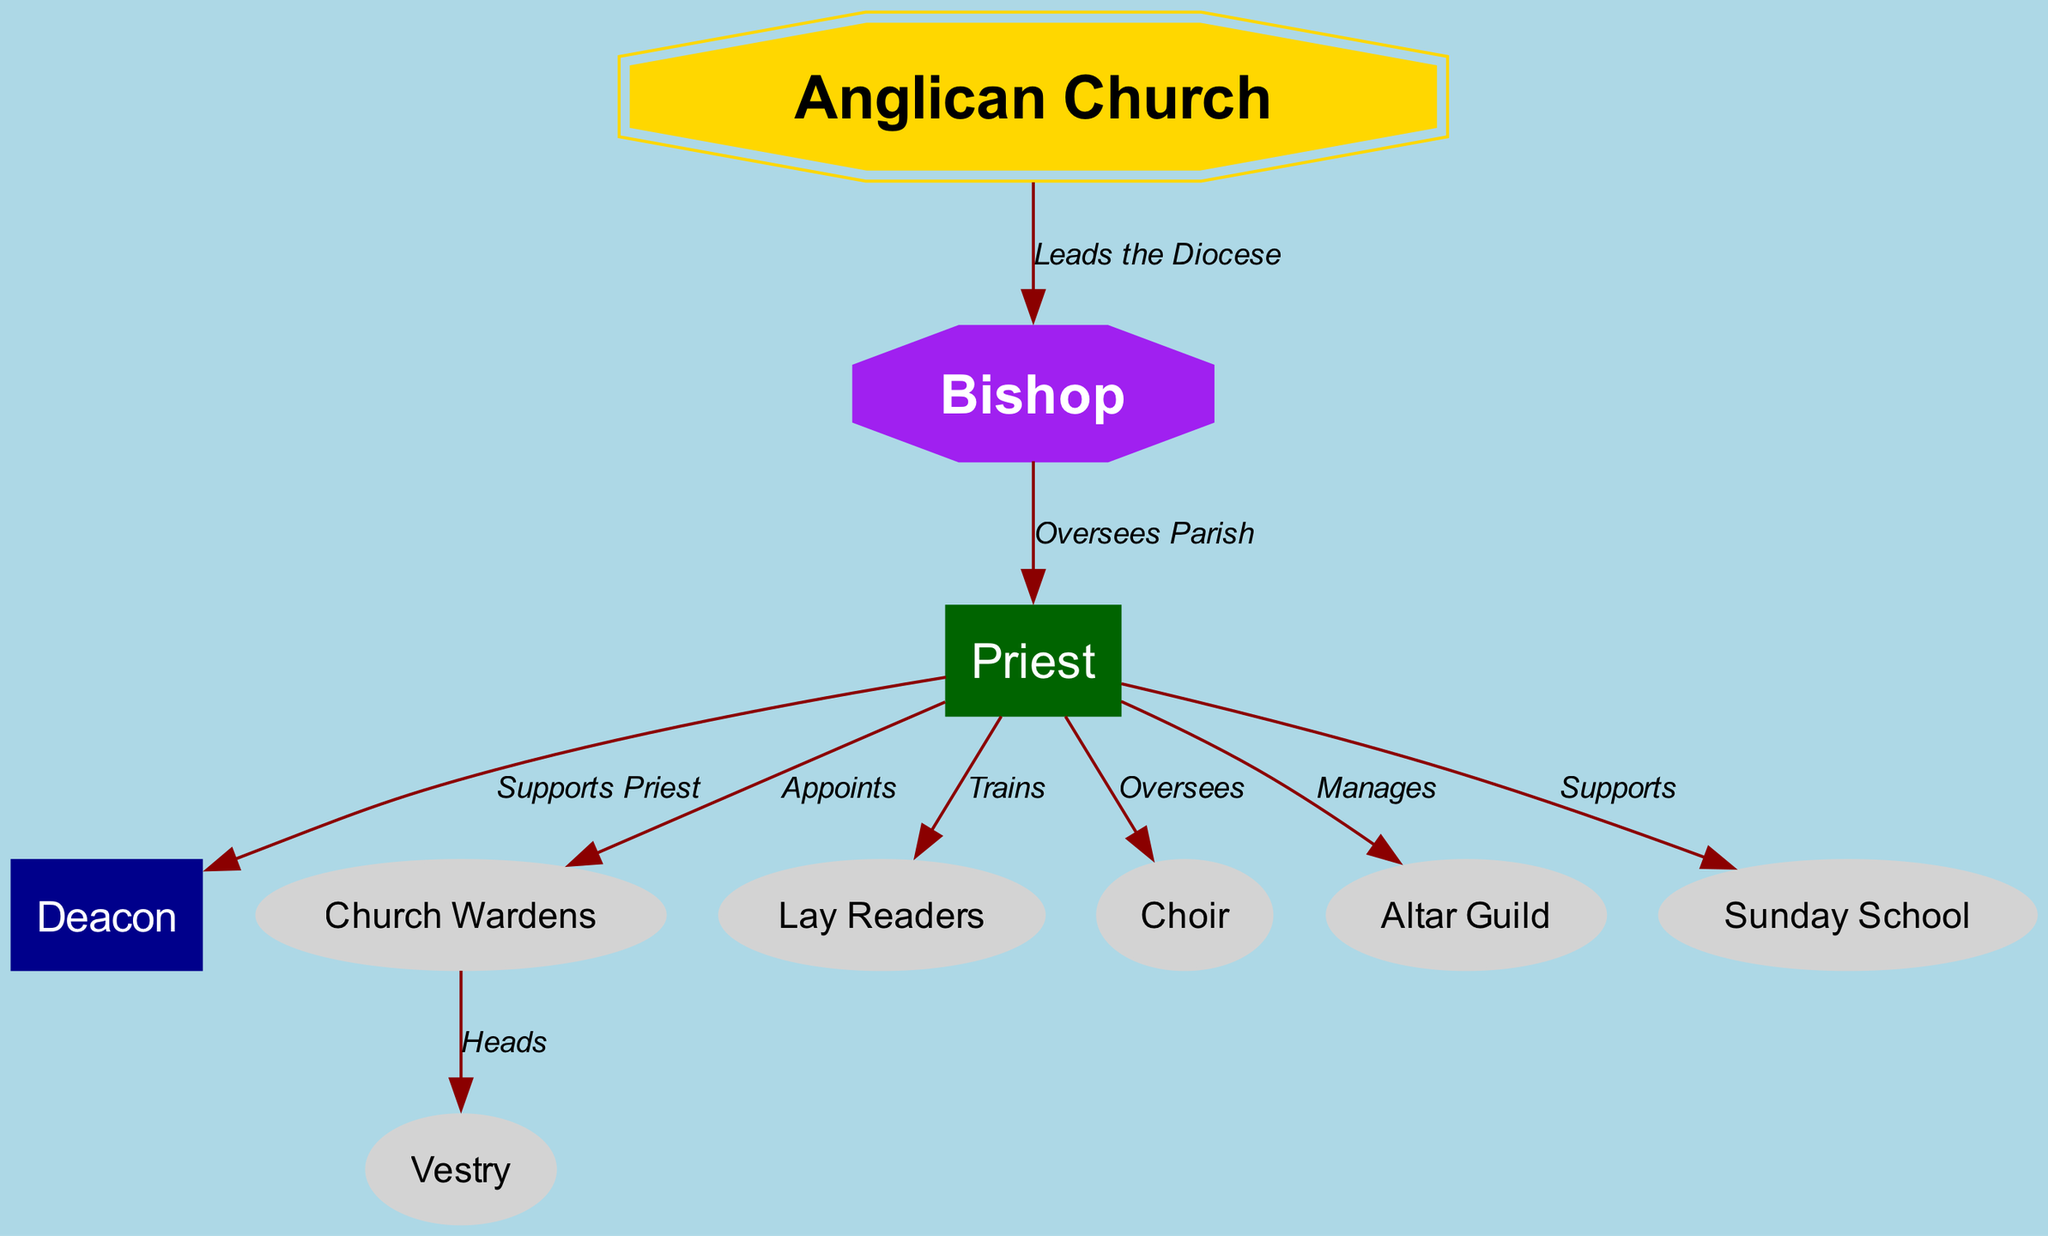What is the top-level entity in the diagram? The top-level entity refers to the most significant node in the organizational structure, which is "Anglican Church." This node is the starting point that connects to the other nodes representing roles within the church.
Answer: Anglican Church How many nodes are present in the diagram? To find the total number of nodes, we can count all entries in the "nodes" section. There are 10 unique nodes listed, which represent the various roles and components of the church.
Answer: 10 What role oversees the parish? The role that oversees the parish is indicated by the directed edge from the "Bishop" to the "Priest," which states that the bishop oversees the parish. This is a key function of the bishop within the Anglican Church.
Answer: Priest Who is appointed by the Priest? The relationship shown in the diagram indicates that the Priest appoints the "Church Wardens." This is clarified in the directed edge indicating the priest's authority to make this appointment.
Answer: Church Wardens Which role manages the Altar Guild? According to the diagram, the Priest manages the Altar Guild, as indicated by the directed edge between these two roles. This shows that the management of the Altar Guild is part of the Priest's responsibilities.
Answer: Altar Guild What is the function of the Deacon in relation to the Priest? The diagram illustrates that the Deacon supports the Priest, as shown by the connecting edge. This indicates the Deacon's role as an assistant and supporter within the church structure.
Answer: Supports Priest Which roles does the Priest oversee? The Priest oversees multiple roles, namely the Deacon, Church Wardens, Lay Readers, Choir, Altar Guild, and Sunday School. This can be deduced by examining the directed edges stemming from the Priest node to these various roles.
Answer: Deacon, Church Wardens, Lay Readers, Choir, Altar Guild, Sunday School How is the Vestry connected to the Church Wardens? The connection indicates that the Church Wardens head the Vestry, which shows a hierarchical relationship where Church Wardens provide leadership for this body that assists in church governance.
Answer: Heads Which role helps train Lay Readers? The diagram illustrates that the Priest is responsible for training Lay Readers as a part of their duties. This relationship is specified through the directed edge labeled "Trains."
Answer: Trains 